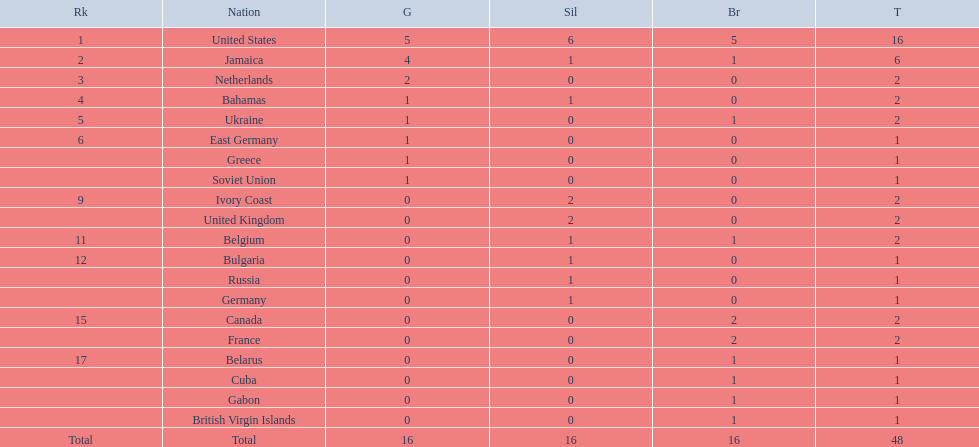What countries competed? United States, Jamaica, Netherlands, Bahamas, Ukraine, East Germany, Greece, Soviet Union, Ivory Coast, United Kingdom, Belgium, Bulgaria, Russia, Germany, Canada, France, Belarus, Cuba, Gabon, British Virgin Islands. Which countries won gold medals? United States, Jamaica, Netherlands, Bahamas, Ukraine, East Germany, Greece, Soviet Union. Which country had the second most medals? Jamaica. 